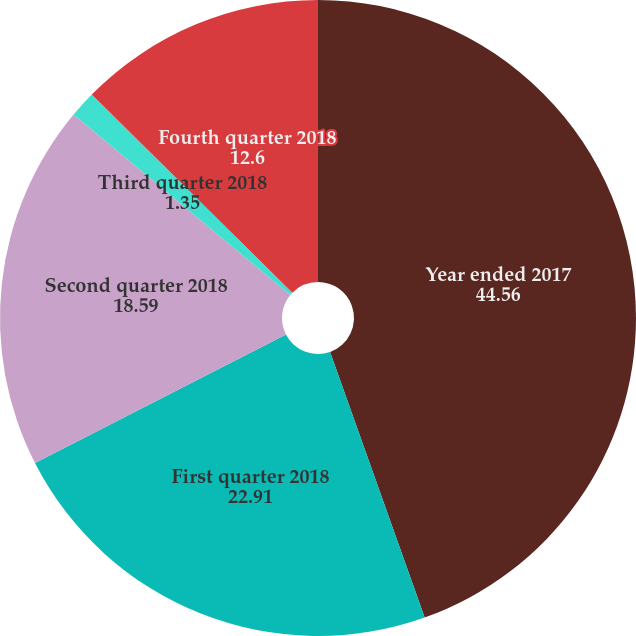<chart> <loc_0><loc_0><loc_500><loc_500><pie_chart><fcel>Year ended 2017<fcel>First quarter 2018<fcel>Second quarter 2018<fcel>Third quarter 2018<fcel>Fourth quarter 2018<nl><fcel>44.56%<fcel>22.91%<fcel>18.59%<fcel>1.35%<fcel>12.6%<nl></chart> 